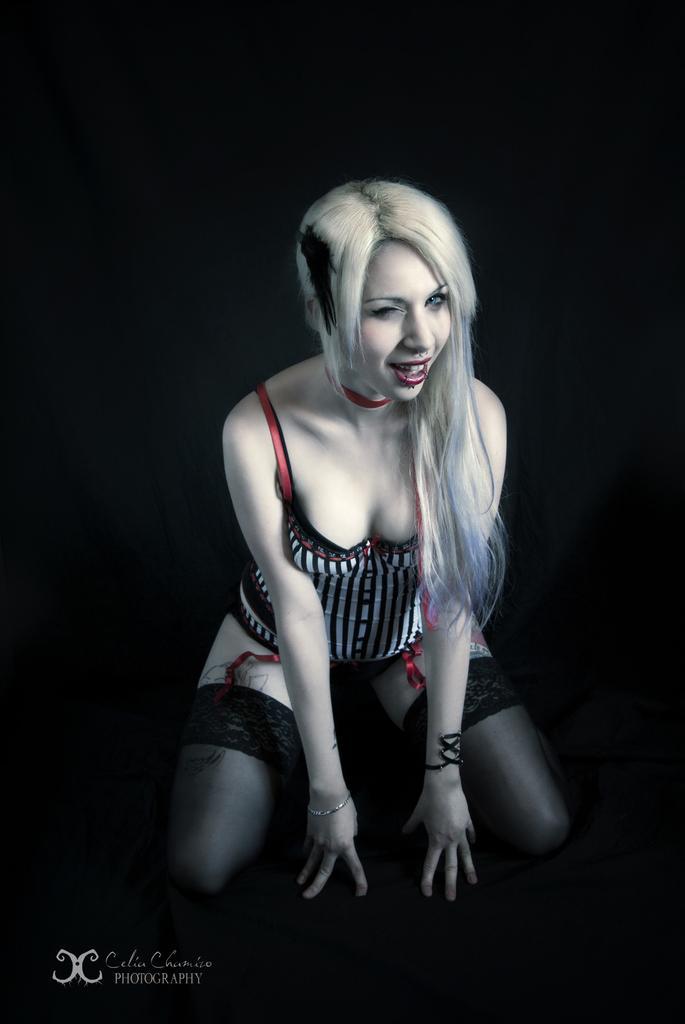Describe this image in one or two sentences. In this picture we can see a woman in the squat position and behind the woman there is a dark background and on the image there is a watermark. 